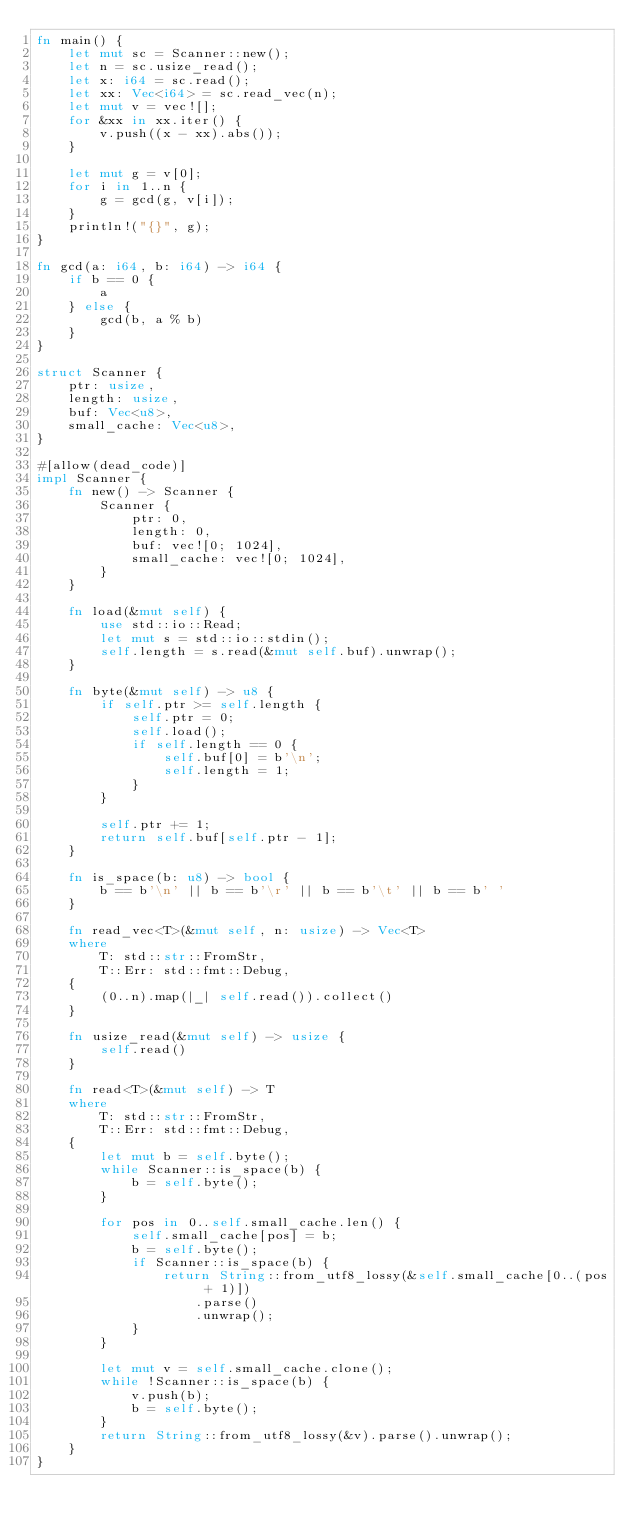<code> <loc_0><loc_0><loc_500><loc_500><_Rust_>fn main() {
    let mut sc = Scanner::new();
    let n = sc.usize_read();
    let x: i64 = sc.read();
    let xx: Vec<i64> = sc.read_vec(n);
    let mut v = vec![];
    for &xx in xx.iter() {
        v.push((x - xx).abs());
    }

    let mut g = v[0];
    for i in 1..n {
        g = gcd(g, v[i]);
    }
    println!("{}", g);
}

fn gcd(a: i64, b: i64) -> i64 {
    if b == 0 {
        a
    } else {
        gcd(b, a % b)
    }
}

struct Scanner {
    ptr: usize,
    length: usize,
    buf: Vec<u8>,
    small_cache: Vec<u8>,
}

#[allow(dead_code)]
impl Scanner {
    fn new() -> Scanner {
        Scanner {
            ptr: 0,
            length: 0,
            buf: vec![0; 1024],
            small_cache: vec![0; 1024],
        }
    }

    fn load(&mut self) {
        use std::io::Read;
        let mut s = std::io::stdin();
        self.length = s.read(&mut self.buf).unwrap();
    }

    fn byte(&mut self) -> u8 {
        if self.ptr >= self.length {
            self.ptr = 0;
            self.load();
            if self.length == 0 {
                self.buf[0] = b'\n';
                self.length = 1;
            }
        }

        self.ptr += 1;
        return self.buf[self.ptr - 1];
    }

    fn is_space(b: u8) -> bool {
        b == b'\n' || b == b'\r' || b == b'\t' || b == b' '
    }

    fn read_vec<T>(&mut self, n: usize) -> Vec<T>
    where
        T: std::str::FromStr,
        T::Err: std::fmt::Debug,
    {
        (0..n).map(|_| self.read()).collect()
    }

    fn usize_read(&mut self) -> usize {
        self.read()
    }

    fn read<T>(&mut self) -> T
    where
        T: std::str::FromStr,
        T::Err: std::fmt::Debug,
    {
        let mut b = self.byte();
        while Scanner::is_space(b) {
            b = self.byte();
        }

        for pos in 0..self.small_cache.len() {
            self.small_cache[pos] = b;
            b = self.byte();
            if Scanner::is_space(b) {
                return String::from_utf8_lossy(&self.small_cache[0..(pos + 1)])
                    .parse()
                    .unwrap();
            }
        }

        let mut v = self.small_cache.clone();
        while !Scanner::is_space(b) {
            v.push(b);
            b = self.byte();
        }
        return String::from_utf8_lossy(&v).parse().unwrap();
    }
}
</code> 